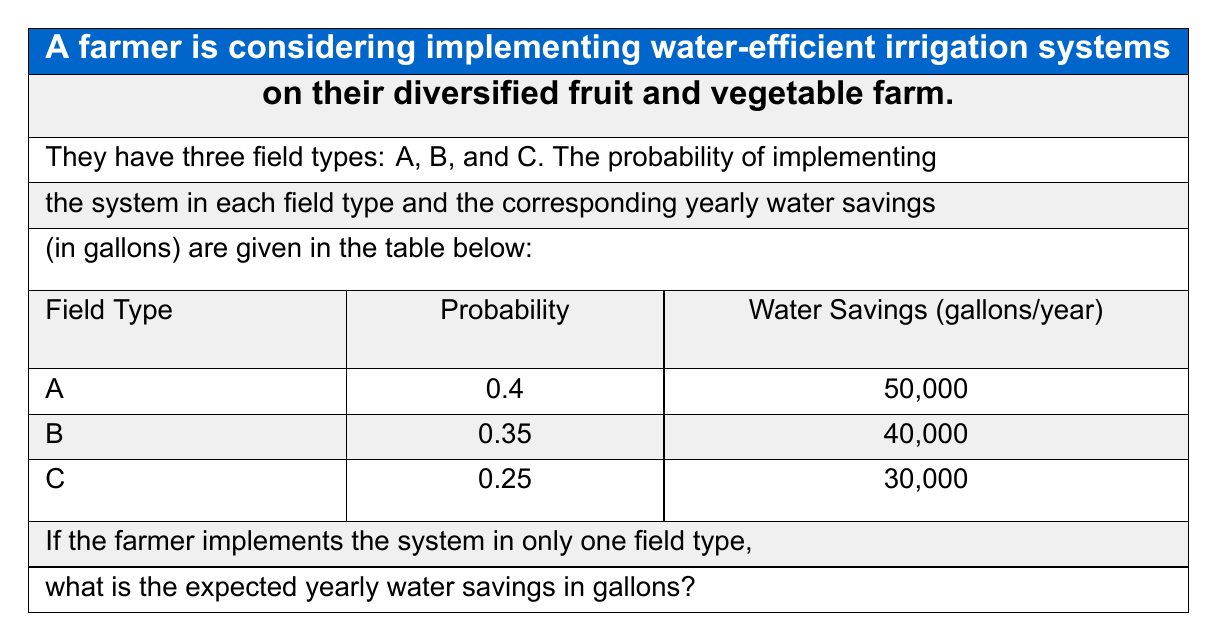Provide a solution to this math problem. To solve this problem, we need to calculate the expected value of the water savings. The expected value is the sum of each possible outcome multiplied by its probability.

Let's break it down step by step:

1) For Field Type A:
   Probability = 0.4
   Water Savings = 50,000 gallons
   Expected Savings for A = $0.4 \times 50,000 = 20,000$ gallons

2) For Field Type B:
   Probability = 0.35
   Water Savings = 40,000 gallons
   Expected Savings for B = $0.35 \times 40,000 = 14,000$ gallons

3) For Field Type C:
   Probability = 0.25
   Water Savings = 30,000 gallons
   Expected Savings for C = $0.25 \times 30,000 = 7,500$ gallons

4) The total expected water savings is the sum of these individual expected values:

   $$E(\text{Water Savings}) = 20,000 + 14,000 + 7,500 = 41,500\text{ gallons}$$

Therefore, the expected yearly water savings is 41,500 gallons.
Answer: 41,500 gallons 